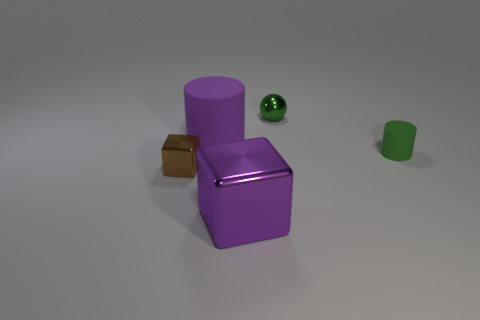What can you infer about the size of the objects relative to each other? The purple cube and cylinder are the largest objects in the image, while the green and brown objects are smaller by comparison. The green ball is the smallest object. 